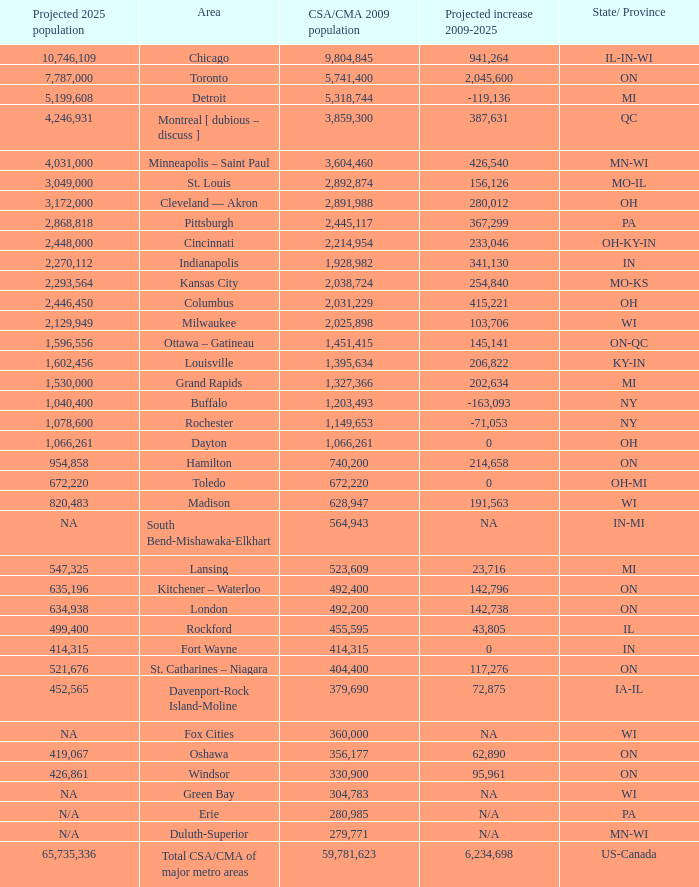What's the projected population of IN-MI? NA. 